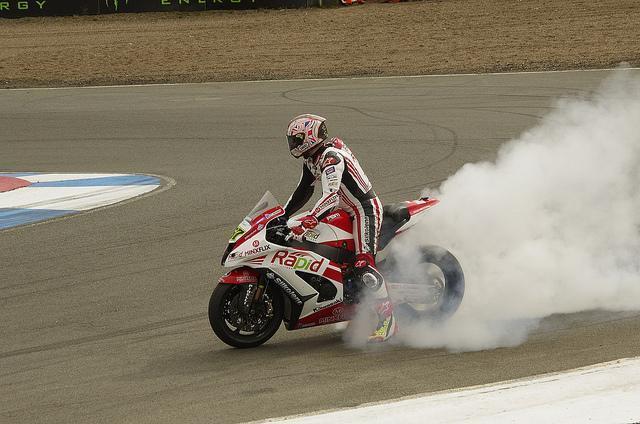How many white remotes do you see?
Give a very brief answer. 0. 